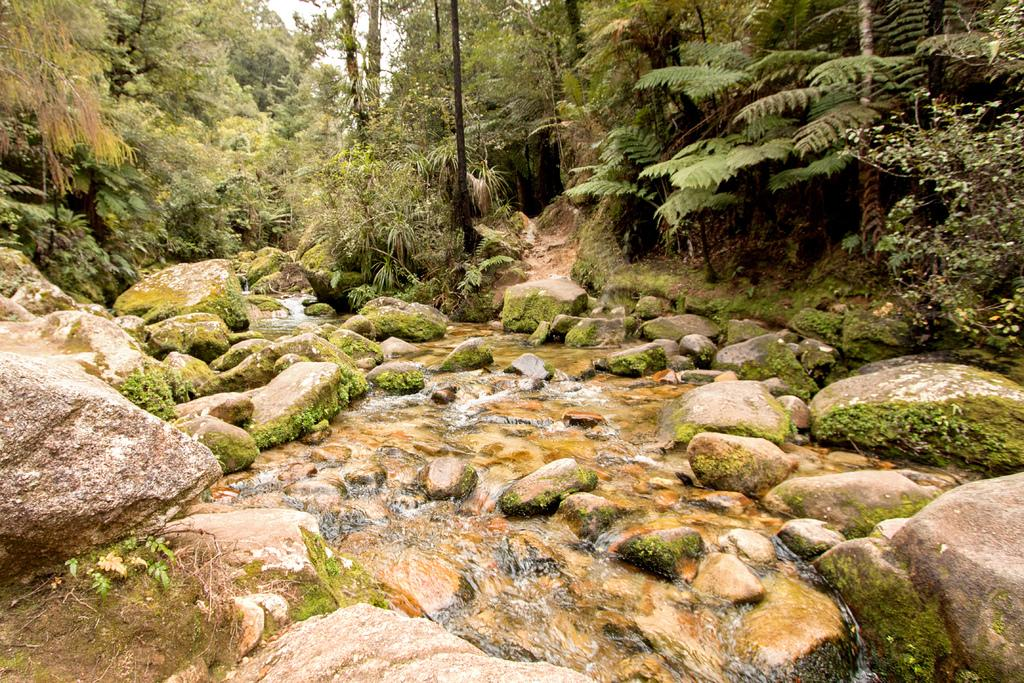What is happening in the image? There is water flowing in the image. What else can be seen in the image besides the water? There are rocks in the image. What can be seen in the background of the image? There are trees visible in the background of the image. How many arms are visible in the image? There are no arms visible in the image. What type of bears can be seen interacting with the water in the image? There are no bears present in the image. 